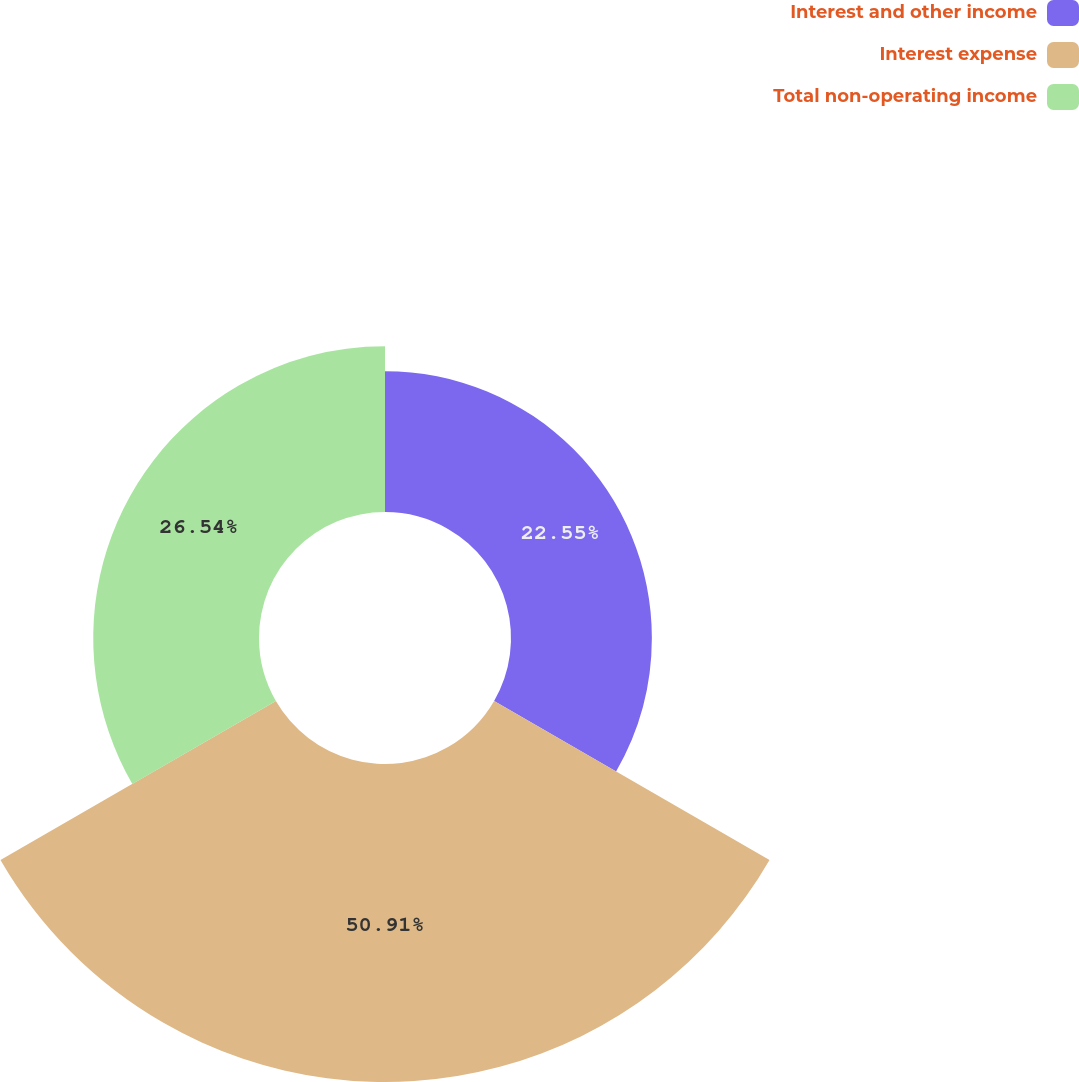Convert chart. <chart><loc_0><loc_0><loc_500><loc_500><pie_chart><fcel>Interest and other income<fcel>Interest expense<fcel>Total non-operating income<nl><fcel>22.55%<fcel>50.91%<fcel>26.54%<nl></chart> 